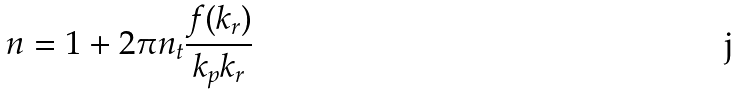<formula> <loc_0><loc_0><loc_500><loc_500>n = 1 + 2 \pi n _ { t } \frac { f ( k _ { r } ) } { k _ { p } k _ { r } }</formula> 